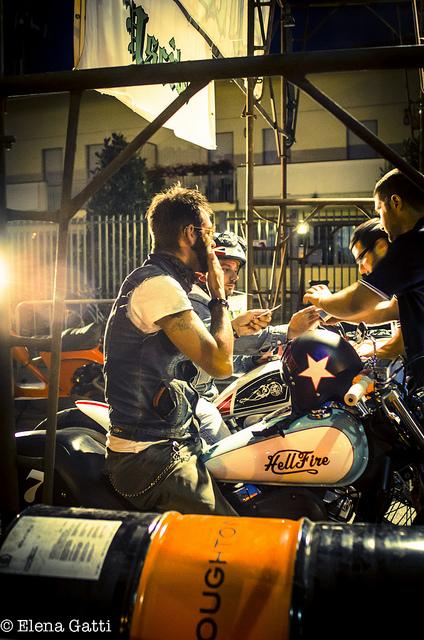What sort of protective gear has the man in the blue vest not put on yet?
Quick response, please. Helmet. Are they boxing?
Short answer required. No. What are the words painted on the gas tank?
Write a very short answer. Hell fire. 